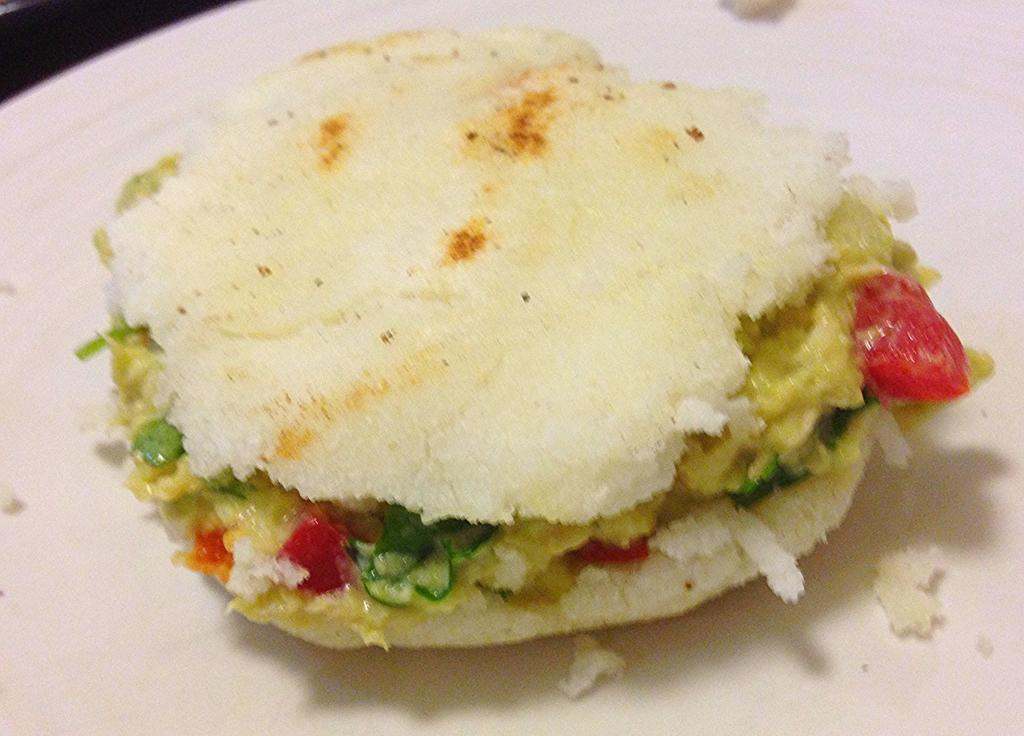What is present on the plate in the image? The plate contains stuffed breasts, which is likely a food item. What type of underwear is visible on the plate in the image? There is no underwear present on the plate in the image; it contains stuffed breasts, likely a food item. 